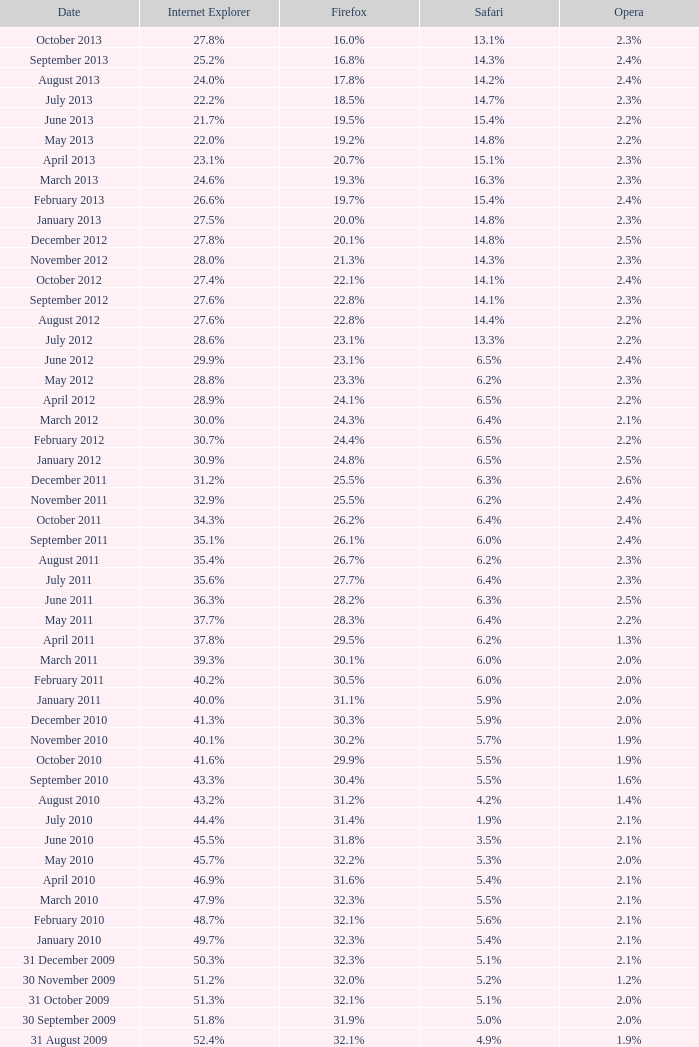2% popularity? 31 January 2008. 